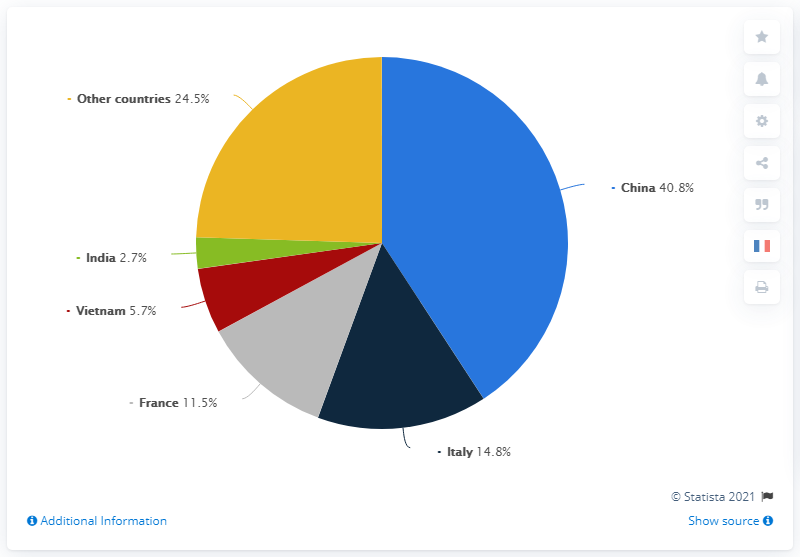Outline some significant characteristics in this image. According to data, in 2019, Vietnam accounted for 5.7% of the global export value of leather goods. In 2019, China accounted for 40.8% of the global value of exported leather goods. In 2018, the total value of leather goods exports from China and Italy was $55.6 billion. According to recent statistics, China is the leading exporter of leather goods in the world. In 2018, the distribution of leather goods exports in value worldwide differed significantly between China and Italy. China was the leading exporter of leather goods, accounting for 37% of the global export value, while Italy represented 24% of the global export value. 